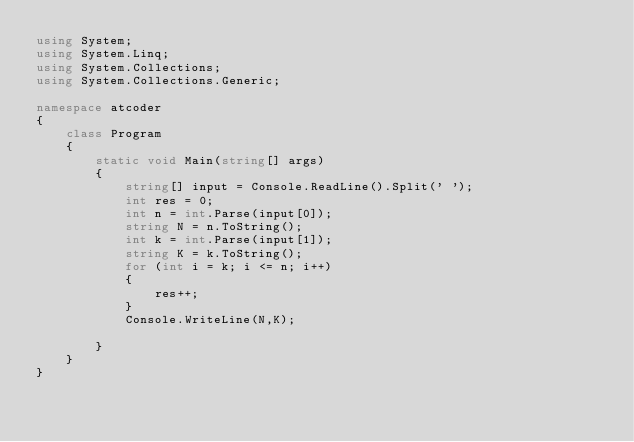<code> <loc_0><loc_0><loc_500><loc_500><_C#_>using System;
using System.Linq;
using System.Collections;
using System.Collections.Generic;

namespace atcoder
{
    class Program
    {
        static void Main(string[] args)
        {
            string[] input = Console.ReadLine().Split(' ');
            int res = 0;
            int n = int.Parse(input[0]);
            string N = n.ToString();
            int k = int.Parse(input[1]);
            string K = k.ToString();
            for (int i = k; i <= n; i++)
            {
                res++;
            }
            Console.WriteLine(N,K);

        }
    }
}</code> 